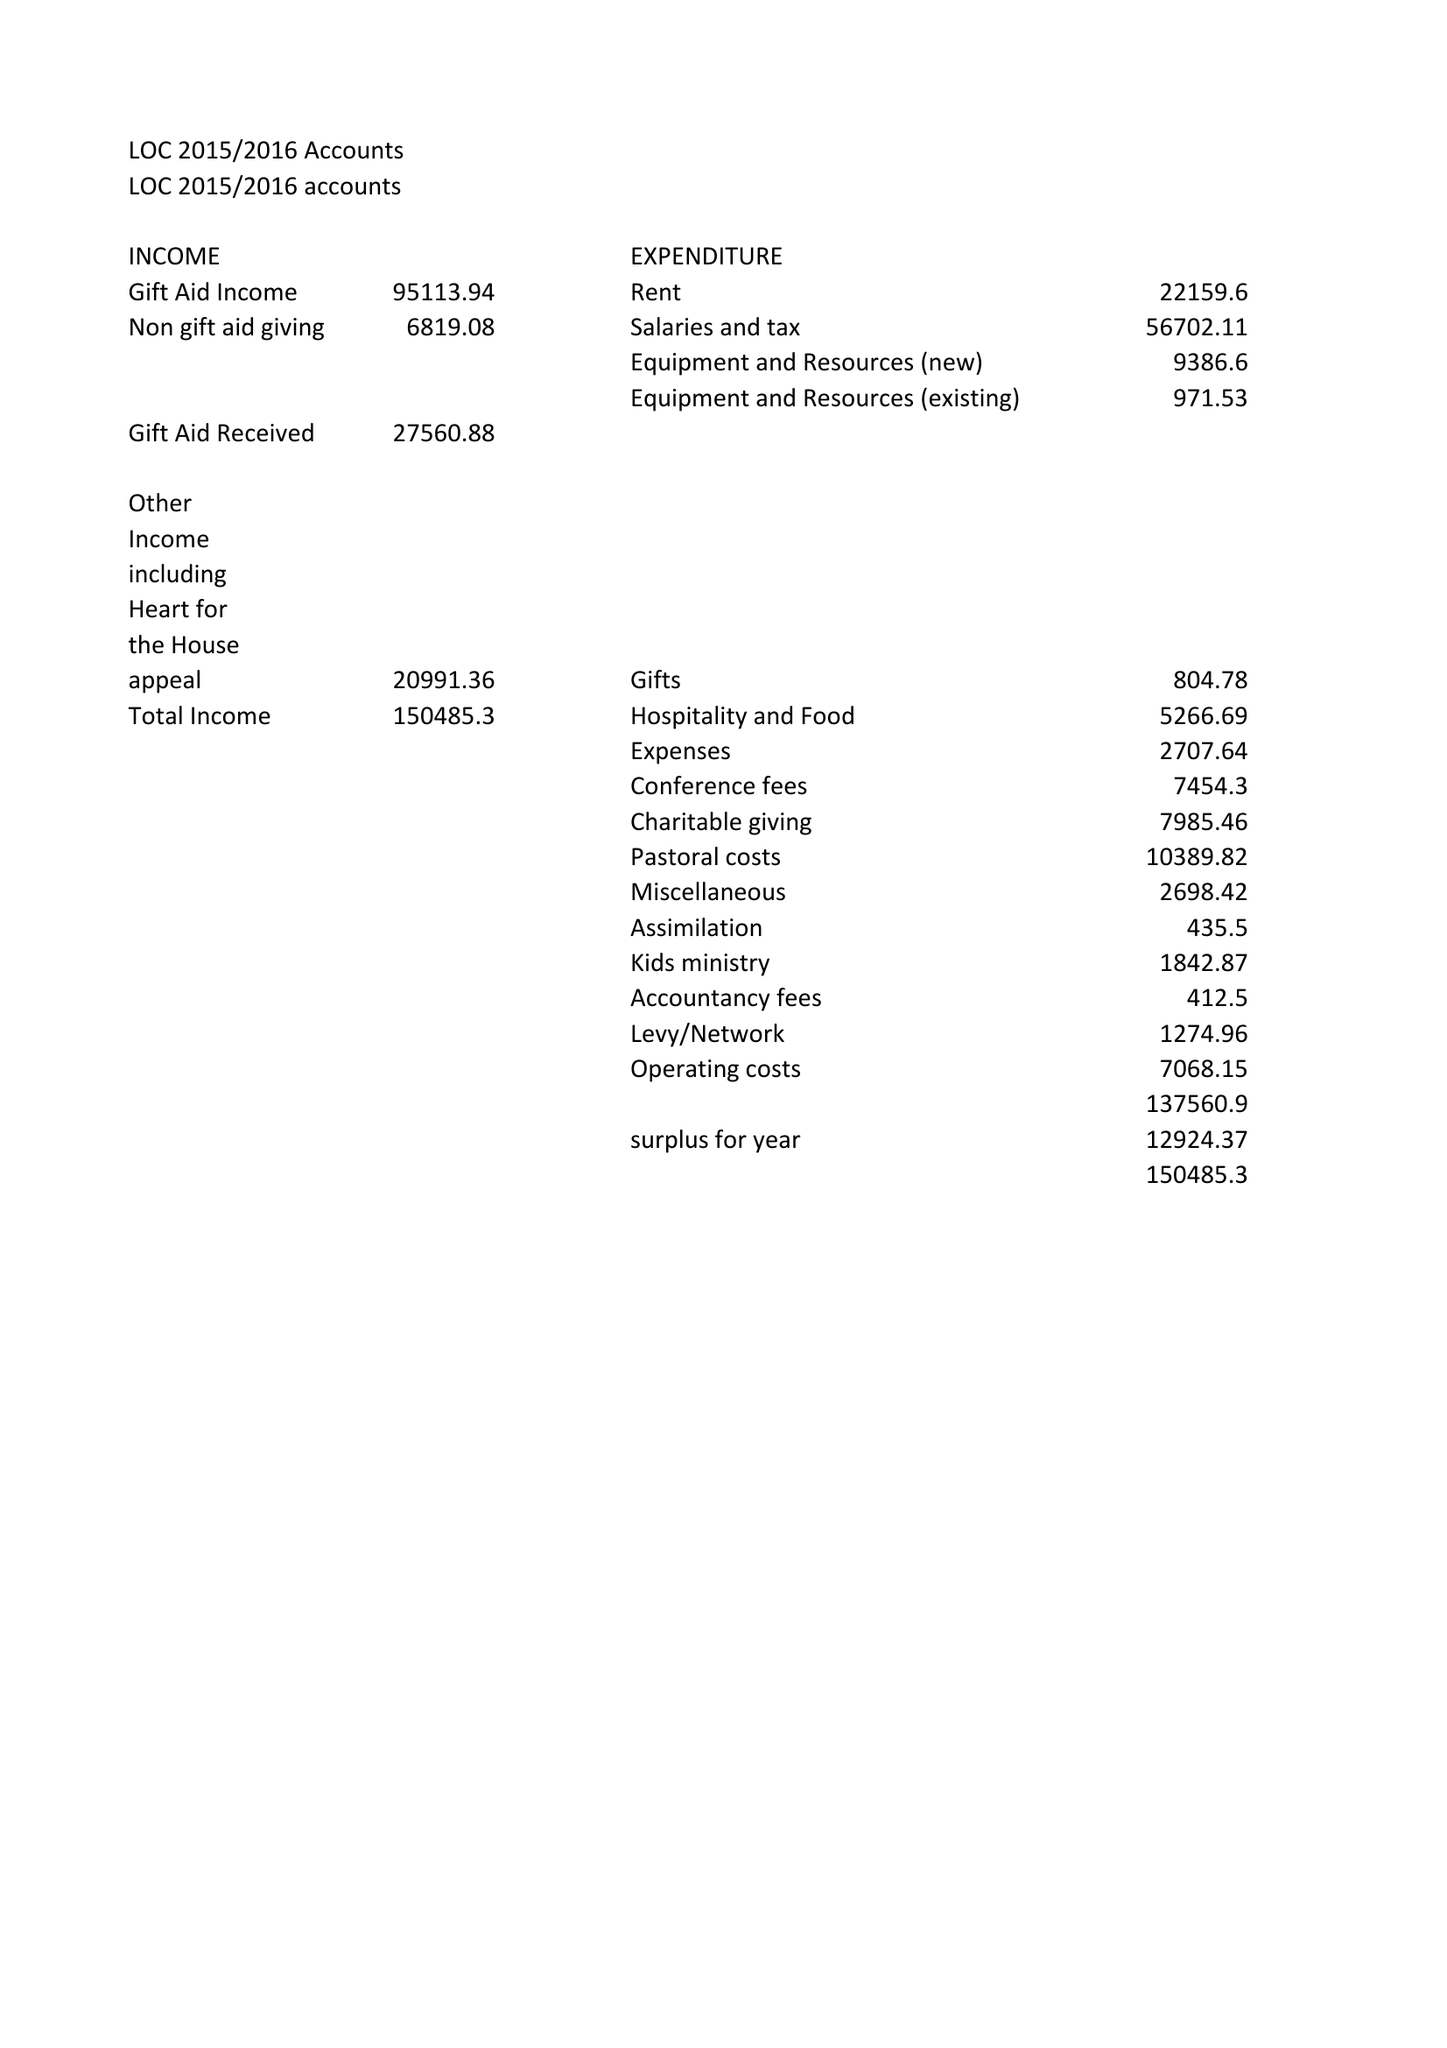What is the value for the address__post_town?
Answer the question using a single word or phrase. None 